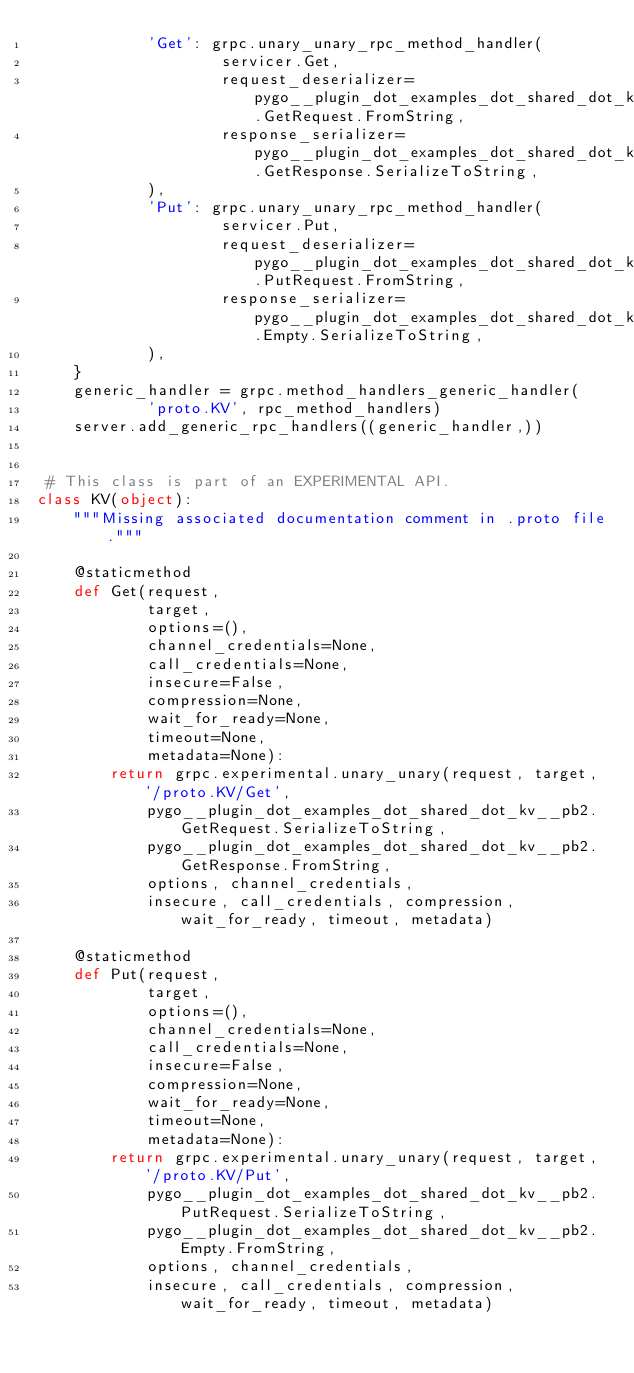Convert code to text. <code><loc_0><loc_0><loc_500><loc_500><_Python_>            'Get': grpc.unary_unary_rpc_method_handler(
                    servicer.Get,
                    request_deserializer=pygo__plugin_dot_examples_dot_shared_dot_kv__pb2.GetRequest.FromString,
                    response_serializer=pygo__plugin_dot_examples_dot_shared_dot_kv__pb2.GetResponse.SerializeToString,
            ),
            'Put': grpc.unary_unary_rpc_method_handler(
                    servicer.Put,
                    request_deserializer=pygo__plugin_dot_examples_dot_shared_dot_kv__pb2.PutRequest.FromString,
                    response_serializer=pygo__plugin_dot_examples_dot_shared_dot_kv__pb2.Empty.SerializeToString,
            ),
    }
    generic_handler = grpc.method_handlers_generic_handler(
            'proto.KV', rpc_method_handlers)
    server.add_generic_rpc_handlers((generic_handler,))


 # This class is part of an EXPERIMENTAL API.
class KV(object):
    """Missing associated documentation comment in .proto file."""

    @staticmethod
    def Get(request,
            target,
            options=(),
            channel_credentials=None,
            call_credentials=None,
            insecure=False,
            compression=None,
            wait_for_ready=None,
            timeout=None,
            metadata=None):
        return grpc.experimental.unary_unary(request, target, '/proto.KV/Get',
            pygo__plugin_dot_examples_dot_shared_dot_kv__pb2.GetRequest.SerializeToString,
            pygo__plugin_dot_examples_dot_shared_dot_kv__pb2.GetResponse.FromString,
            options, channel_credentials,
            insecure, call_credentials, compression, wait_for_ready, timeout, metadata)

    @staticmethod
    def Put(request,
            target,
            options=(),
            channel_credentials=None,
            call_credentials=None,
            insecure=False,
            compression=None,
            wait_for_ready=None,
            timeout=None,
            metadata=None):
        return grpc.experimental.unary_unary(request, target, '/proto.KV/Put',
            pygo__plugin_dot_examples_dot_shared_dot_kv__pb2.PutRequest.SerializeToString,
            pygo__plugin_dot_examples_dot_shared_dot_kv__pb2.Empty.FromString,
            options, channel_credentials,
            insecure, call_credentials, compression, wait_for_ready, timeout, metadata)
</code> 